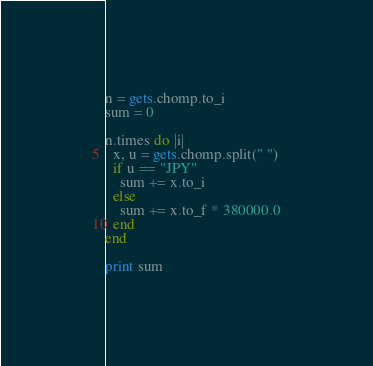<code> <loc_0><loc_0><loc_500><loc_500><_Ruby_>n = gets.chomp.to_i
sum = 0

n.times do |i|
  x, u = gets.chomp.split(" ")
  if u == "JPY"
    sum += x.to_i
  else
    sum += x.to_f * 380000.0
  end
end

print sum</code> 